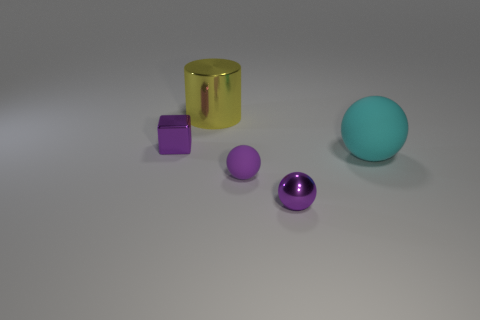Subtract all cyan matte spheres. How many spheres are left? 2 Subtract all cyan balls. How many balls are left? 2 Add 5 purple objects. How many objects exist? 10 Subtract all balls. How many objects are left? 2 Subtract 2 balls. How many balls are left? 1 Subtract all cyan cylinders. How many purple spheres are left? 2 Subtract all big purple shiny cylinders. Subtract all small metal objects. How many objects are left? 3 Add 3 big metallic cylinders. How many big metallic cylinders are left? 4 Add 5 small purple matte cubes. How many small purple matte cubes exist? 5 Subtract 0 blue cylinders. How many objects are left? 5 